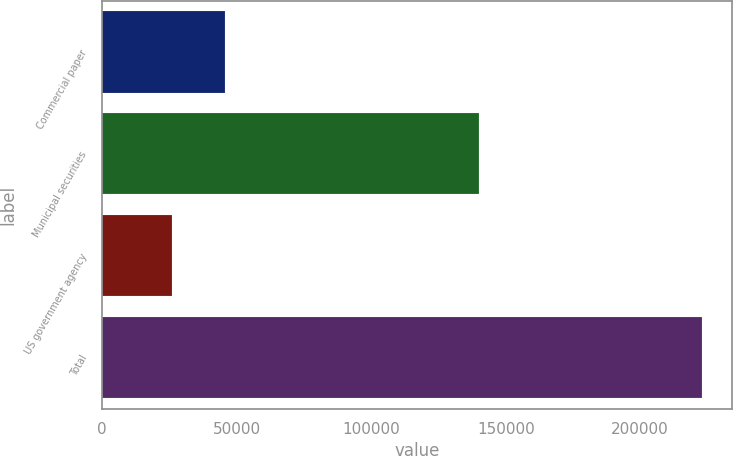Convert chart to OTSL. <chart><loc_0><loc_0><loc_500><loc_500><bar_chart><fcel>Commercial paper<fcel>Municipal securities<fcel>US government agency<fcel>Total<nl><fcel>45740.7<fcel>140198<fcel>26051<fcel>222948<nl></chart> 